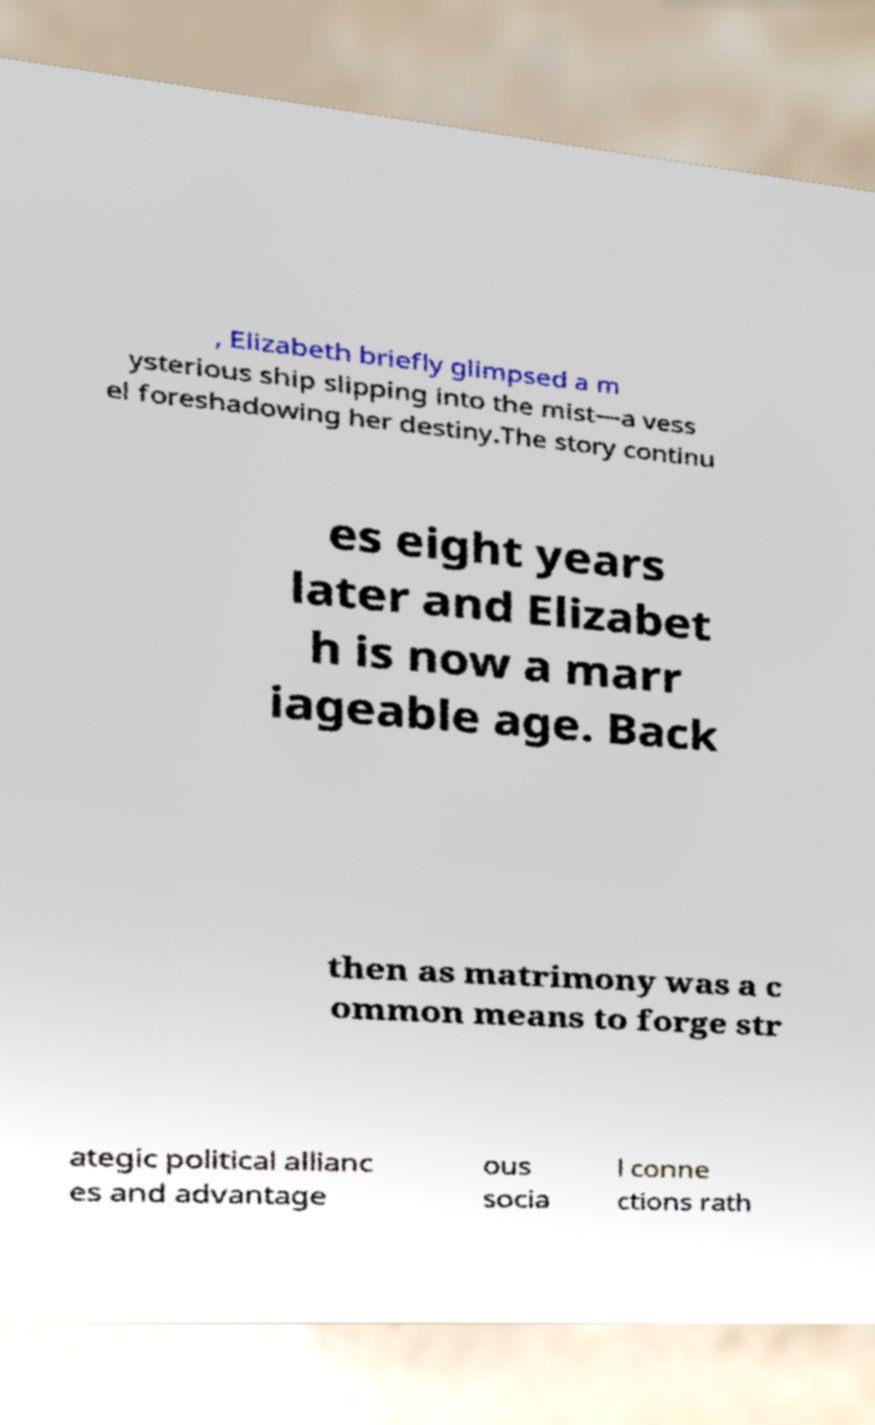For documentation purposes, I need the text within this image transcribed. Could you provide that? , Elizabeth briefly glimpsed a m ysterious ship slipping into the mist—a vess el foreshadowing her destiny.The story continu es eight years later and Elizabet h is now a marr iageable age. Back then as matrimony was a c ommon means to forge str ategic political allianc es and advantage ous socia l conne ctions rath 